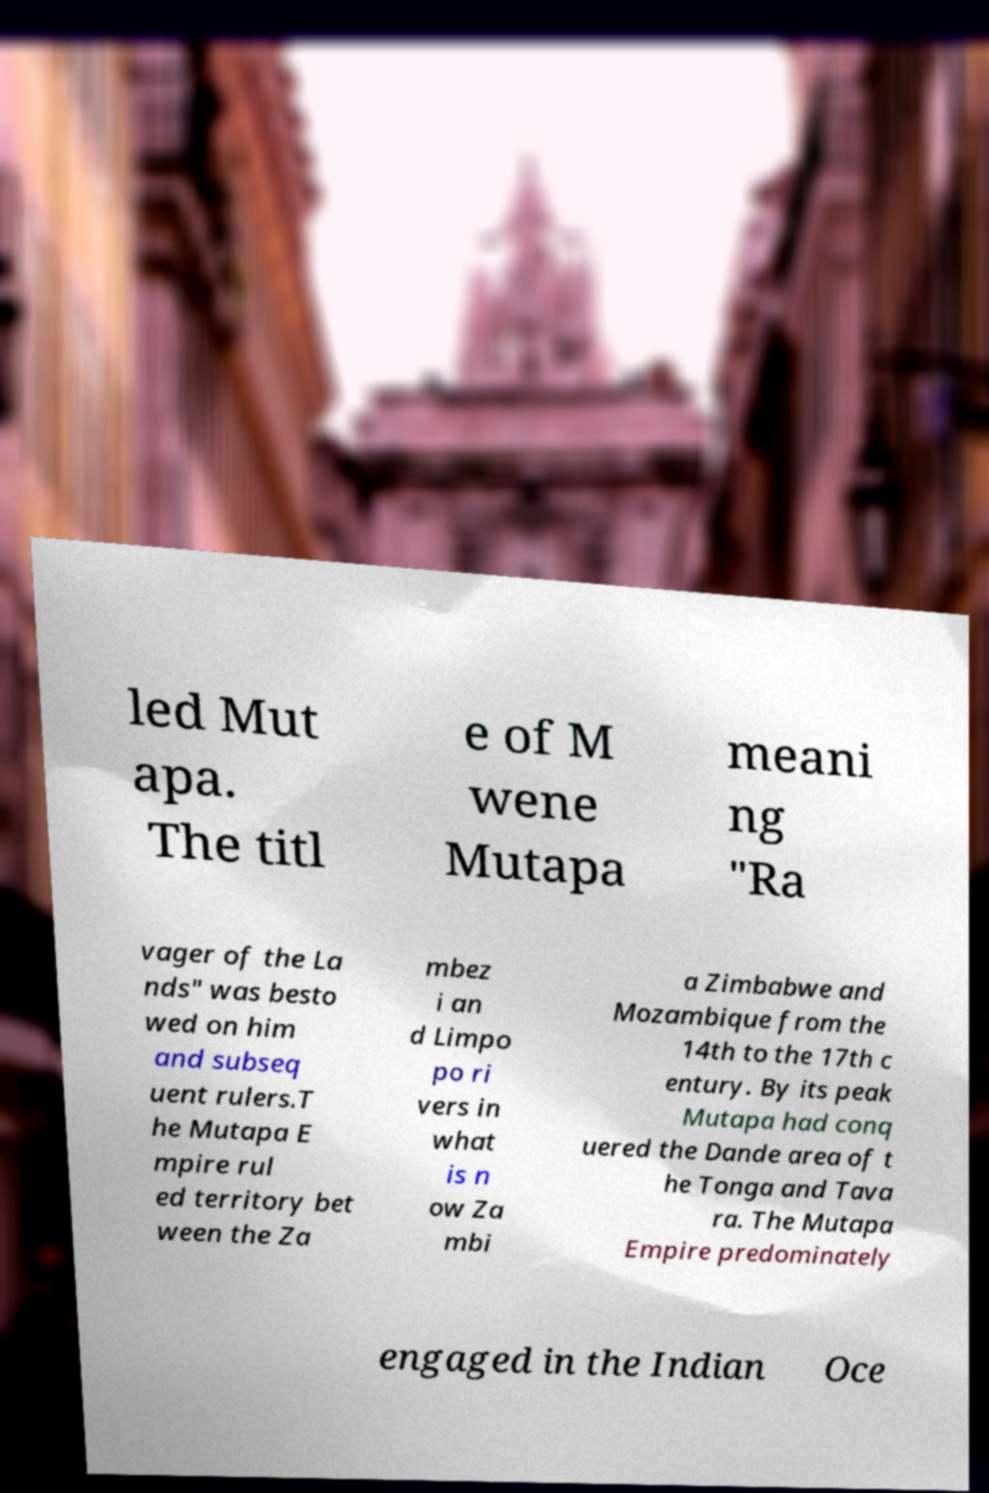I need the written content from this picture converted into text. Can you do that? led Mut apa. The titl e of M wene Mutapa meani ng "Ra vager of the La nds" was besto wed on him and subseq uent rulers.T he Mutapa E mpire rul ed territory bet ween the Za mbez i an d Limpo po ri vers in what is n ow Za mbi a Zimbabwe and Mozambique from the 14th to the 17th c entury. By its peak Mutapa had conq uered the Dande area of t he Tonga and Tava ra. The Mutapa Empire predominately engaged in the Indian Oce 